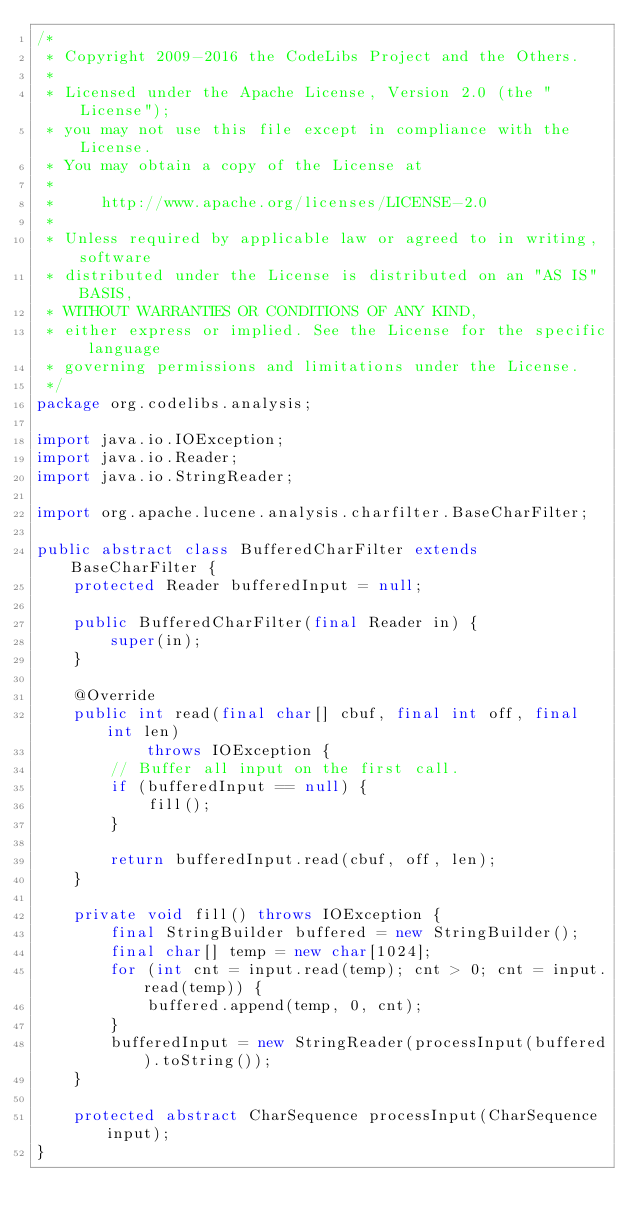Convert code to text. <code><loc_0><loc_0><loc_500><loc_500><_Java_>/*
 * Copyright 2009-2016 the CodeLibs Project and the Others.
 *
 * Licensed under the Apache License, Version 2.0 (the "License");
 * you may not use this file except in compliance with the License.
 * You may obtain a copy of the License at
 *
 *     http://www.apache.org/licenses/LICENSE-2.0
 *
 * Unless required by applicable law or agreed to in writing, software
 * distributed under the License is distributed on an "AS IS" BASIS,
 * WITHOUT WARRANTIES OR CONDITIONS OF ANY KIND,
 * either express or implied. See the License for the specific language
 * governing permissions and limitations under the License.
 */
package org.codelibs.analysis;

import java.io.IOException;
import java.io.Reader;
import java.io.StringReader;

import org.apache.lucene.analysis.charfilter.BaseCharFilter;

public abstract class BufferedCharFilter extends BaseCharFilter {
    protected Reader bufferedInput = null;

    public BufferedCharFilter(final Reader in) {
        super(in);
    }

    @Override
    public int read(final char[] cbuf, final int off, final int len)
            throws IOException {
        // Buffer all input on the first call.
        if (bufferedInput == null) {
            fill();
        }

        return bufferedInput.read(cbuf, off, len);
    }

    private void fill() throws IOException {
        final StringBuilder buffered = new StringBuilder();
        final char[] temp = new char[1024];
        for (int cnt = input.read(temp); cnt > 0; cnt = input.read(temp)) {
            buffered.append(temp, 0, cnt);
        }
        bufferedInput = new StringReader(processInput(buffered).toString());
    }

    protected abstract CharSequence processInput(CharSequence input);
}
</code> 